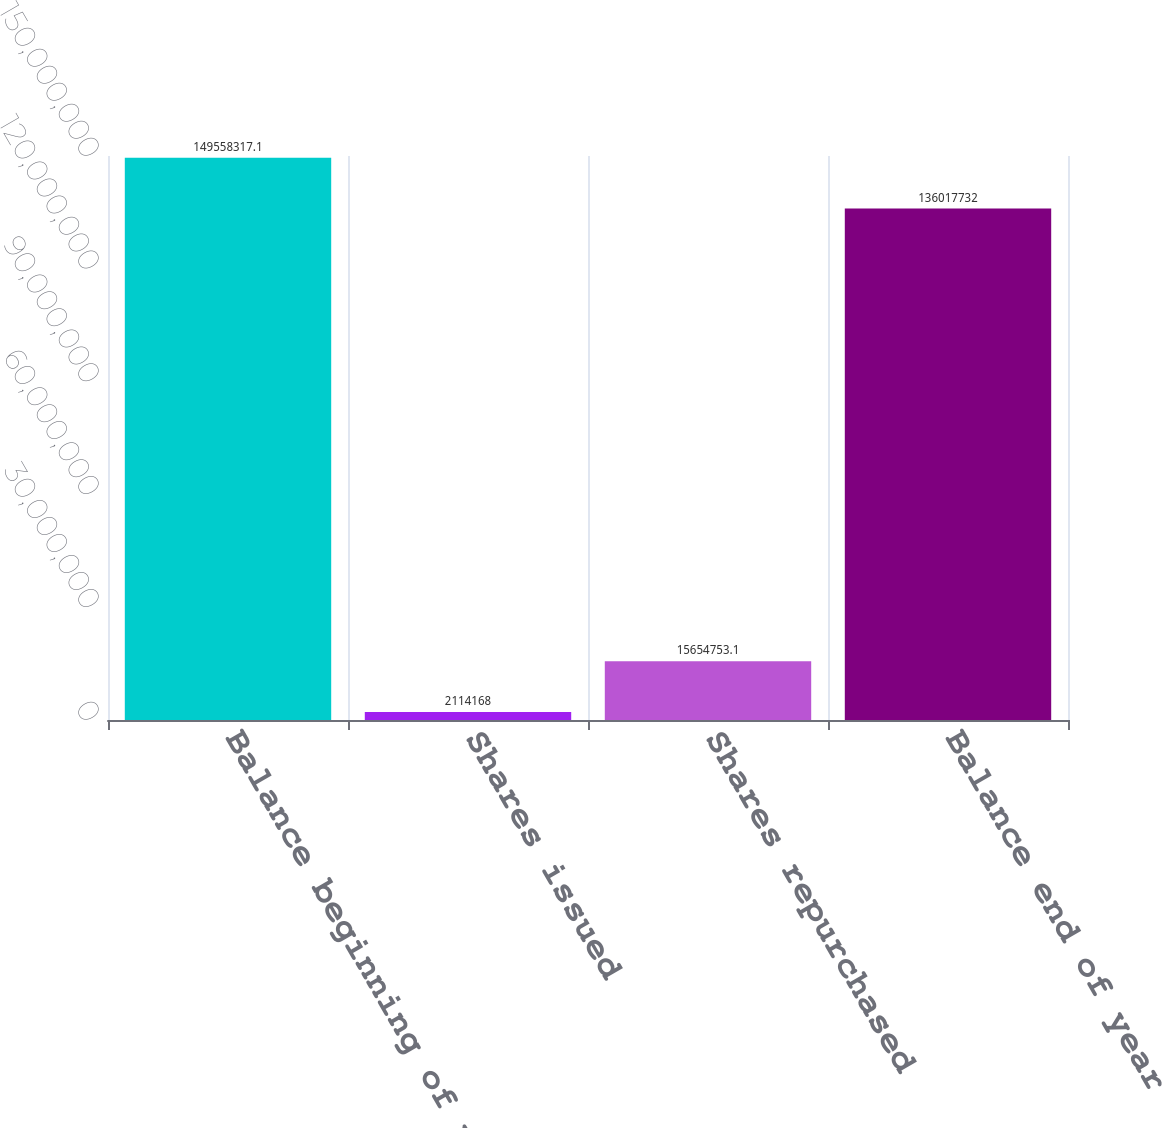<chart> <loc_0><loc_0><loc_500><loc_500><bar_chart><fcel>Balance beginning of year<fcel>Shares issued<fcel>Shares repurchased<fcel>Balance end of year<nl><fcel>1.49558e+08<fcel>2.11417e+06<fcel>1.56548e+07<fcel>1.36018e+08<nl></chart> 